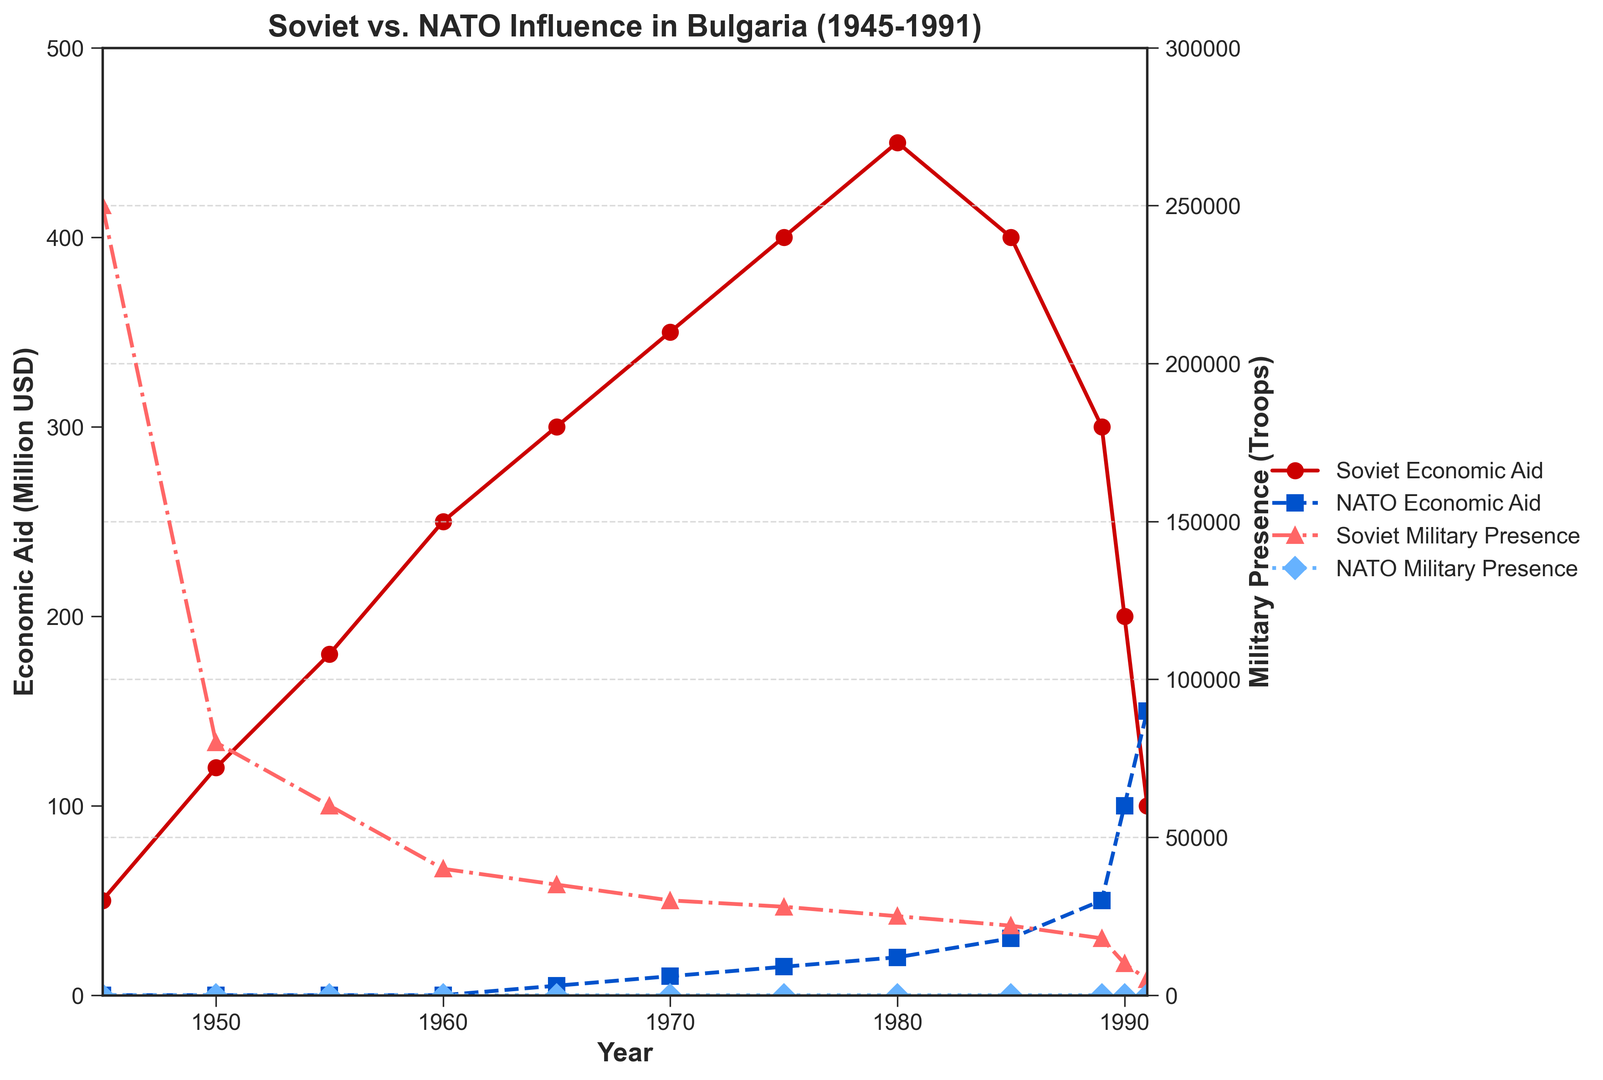What's the trend of Soviet Economic Aid from 1945 to 1991? Soviet Economic Aid starts at 50 million USD in 1945 and increases steadily until it peaks at 450 million USD in 1980. It then begins to decline, reaching 100 million USD by 1991.
Answer: Increase until 1980, then decrease When did NATO Economic Aid exceed Soviet Economic Aid for the first time? NATO Economic Aid first exceeds Soviet Economic Aid in 1991, where NATO provides 150 million USD compared to the Soviet's 100 million USD.
Answer: 1991 At what year did Soviet Military Presence decline the most sharply? Soviet Military Presence declined most sharply between 1945 and 1950, from 250,000 to 80,000 troops, a reduction of 170,000.
Answer: Between 1945-1950 How does NATO Military Presence compare to Soviet Military Presence throughout the period? NATO Military Presence is zero throughout the entire period from 1945 to 1991, while Soviet Military Presence shows significant numbers, starting at 250,000 and decreasing to 5,000.
Answer: NATO = 0; Soviet presence significant but decreasing What is the visual difference between the trends of Soviet Military Presence and NATO Military Presence over the period? Soviet Military Presence is represented by a red-circled line, showing a significant decline over time. NATO Military Presence is depicted by a blue-diamond line, remaining consistently at zero throughout the period.
Answer: Soviet decreases; NATO constant at zero By how much did Soviet Economic Aid increase from 1945 to its peak in 1980? Soviet Economic Aid increased from 50 million USD in 1945 to 450 million USD in 1980. The difference is calculated as 450 - 50 = 400 million USD.
Answer: 400 million USD In which decade did NATO start providing economic aid to Bulgaria, and how did it change over time? NATO started providing economic aid in the 1960s. It began with 5 million USD in 1965, gradually increasing to 150 million USD by 1991.
Answer: 1965, gradual increase What is the relationship between the changes in Soviet Economic Aid and Military Presence around 1980? Around 1980, Soviet Economic Aid peaked at 450 million USD, while Military Presence showed a continuous decline. This suggests an economic peak amidst reducing military commitment.
Answer: Economic Aid peaks; Military Presence declines Which year shows the closest values between Soviet and NATO Economic Aid? In 1991, Soviet Economic Aid is 100 million USD, and NATO Economic Aid is 150 million USD, showing a close range as compared to other years.
Answer: 1991 What is the percentage decrease in Soviet Military Presence from its peak in 1945 to its lowest in 1991? The Soviet Military Presence decreased from 250,000 troops in 1945 to 5,000 troops in 1991. The percentage decrease is calculated as ((250,000 - 5,000) / 250,000) * 100 = 98%.
Answer: 98% 